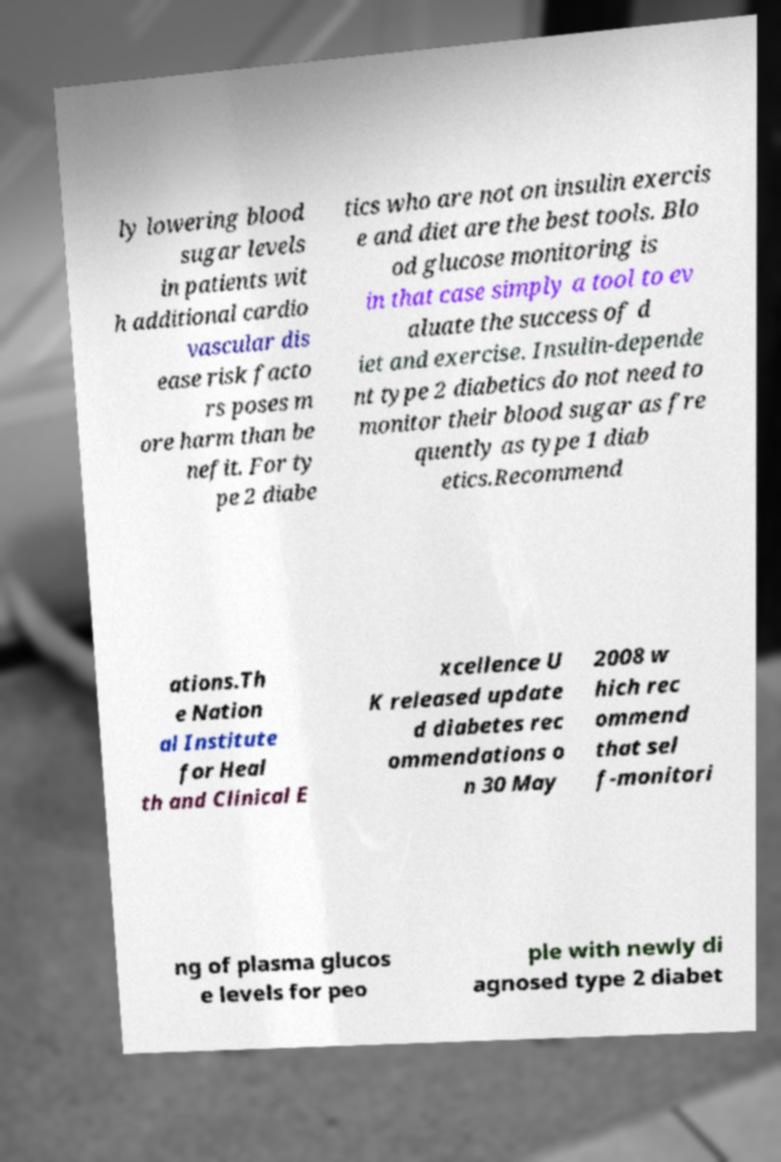Can you accurately transcribe the text from the provided image for me? ly lowering blood sugar levels in patients wit h additional cardio vascular dis ease risk facto rs poses m ore harm than be nefit. For ty pe 2 diabe tics who are not on insulin exercis e and diet are the best tools. Blo od glucose monitoring is in that case simply a tool to ev aluate the success of d iet and exercise. Insulin-depende nt type 2 diabetics do not need to monitor their blood sugar as fre quently as type 1 diab etics.Recommend ations.Th e Nation al Institute for Heal th and Clinical E xcellence U K released update d diabetes rec ommendations o n 30 May 2008 w hich rec ommend that sel f-monitori ng of plasma glucos e levels for peo ple with newly di agnosed type 2 diabet 